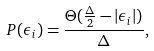<formula> <loc_0><loc_0><loc_500><loc_500>P ( \epsilon _ { i } ) = \frac { \Theta ( \frac { \Delta } { 2 } - | \epsilon _ { i } | ) } { \Delta } ,</formula> 